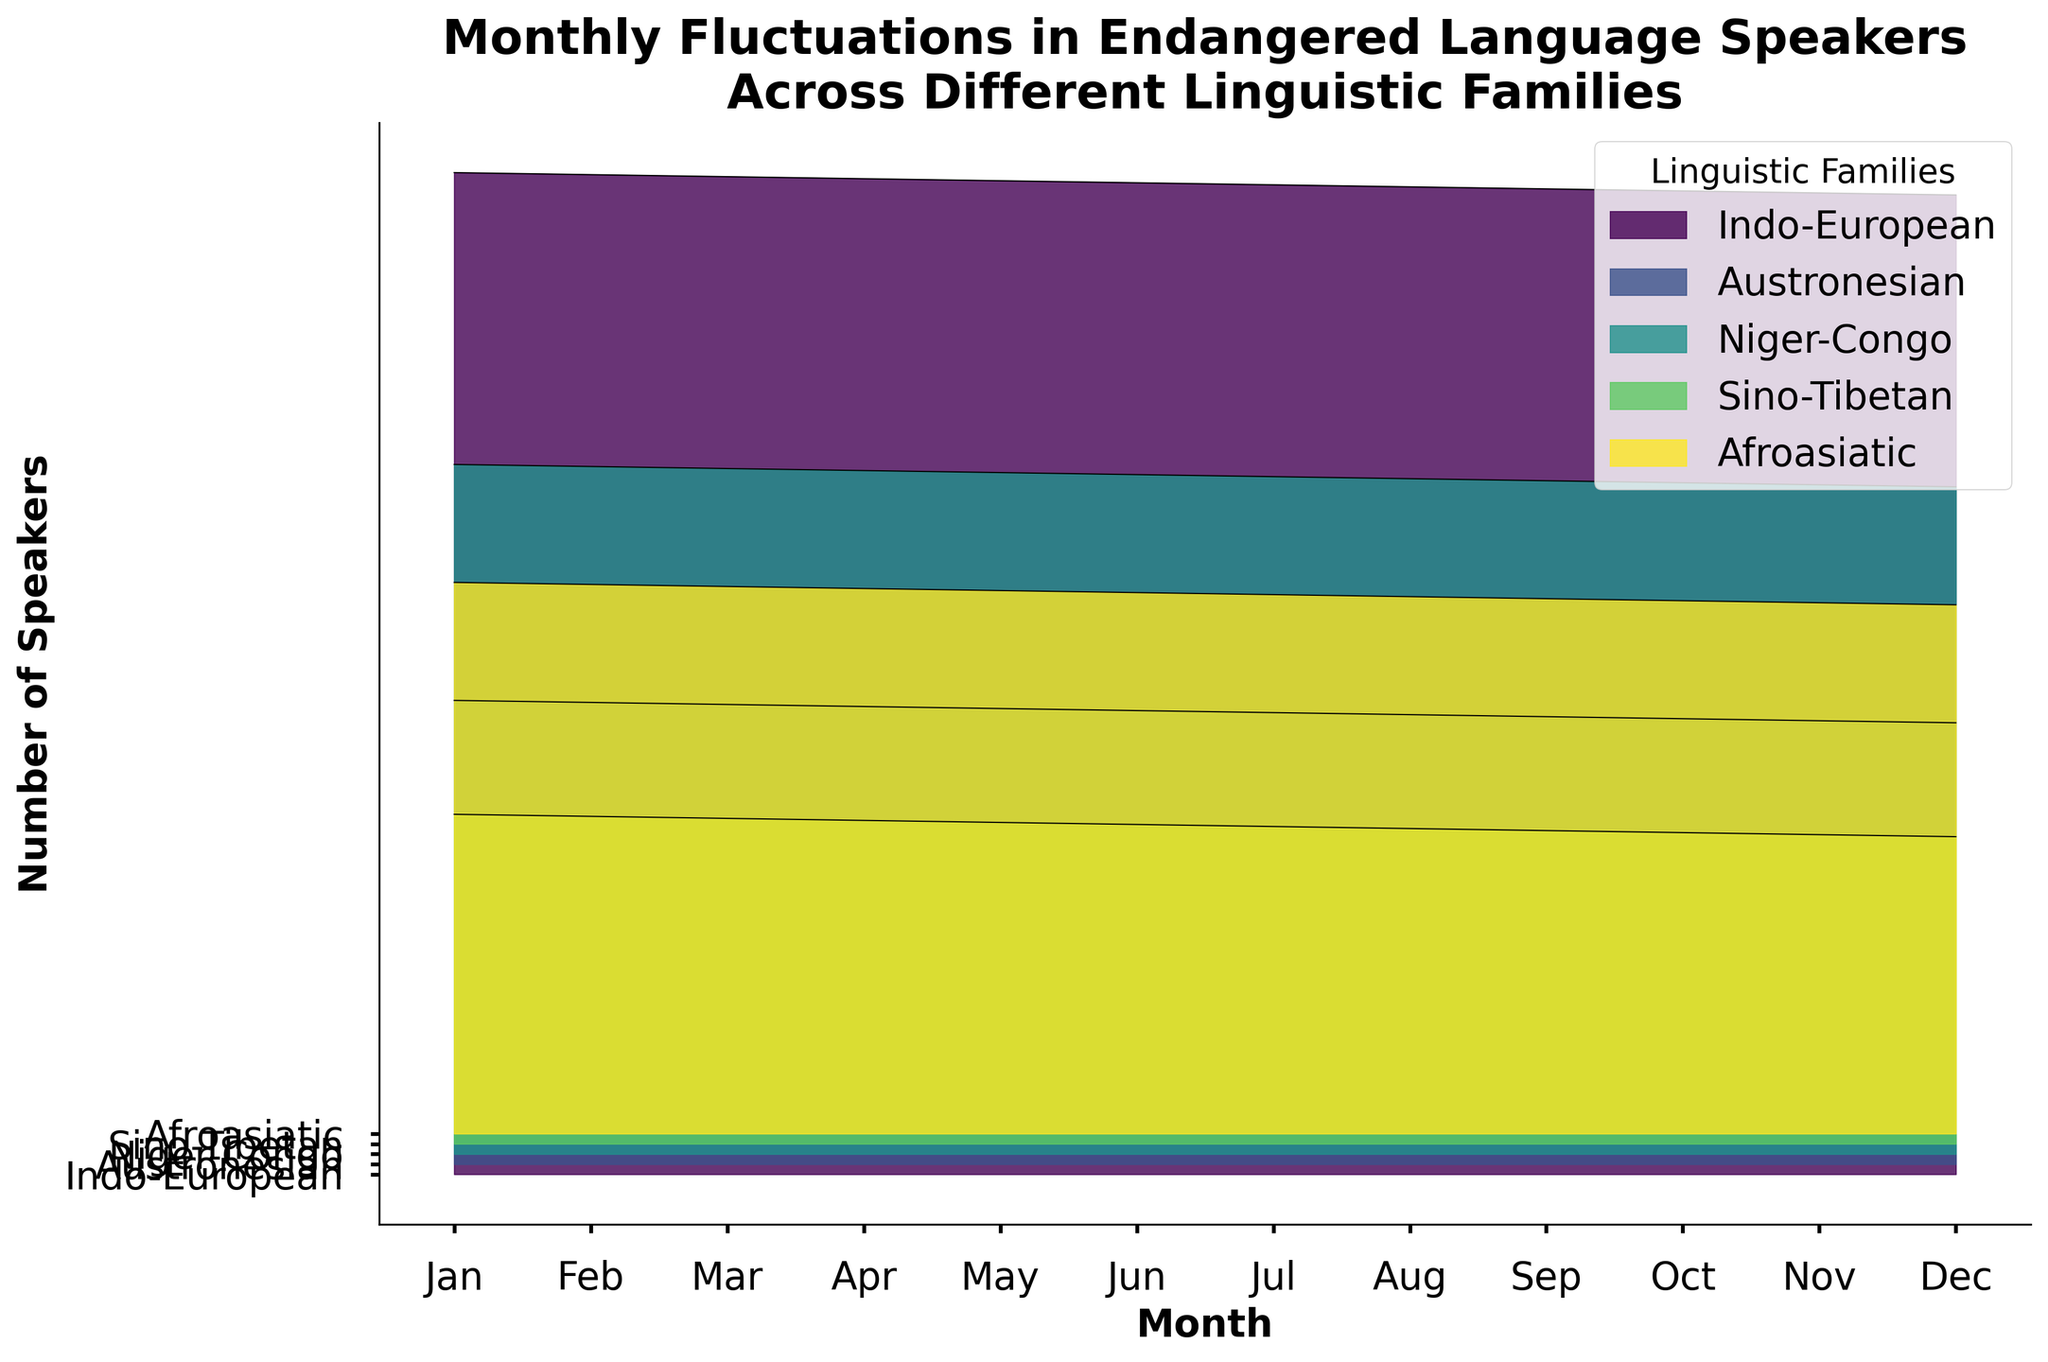What is the title of the plot? The title of the plot is typically located at the top of the figure, and it summarizes the content.
Answer: Monthly Fluctuations in Endangered Language Speakers Across Different Linguistic Families Which linguistic family has the highest number of speakers in January? By observing the Ridgeline plot for the month of January and following the line upwards, we look for the highest peak.
Answer: Indo-European How many linguistic families are presented in the plot? The y-axis of the Ridgeline plot typically lists all the categories. By counting the labels on the y-axis, we determine the number of linguistic families.
Answer: 5 What is the primary color used for the Indo-European linguistic family? By identifying the section related to the Indo-European family in the plot, we observe the color fill used.
Answer: Green What is the difference in the number of speakers between January and February for the Niger-Congo family? Locate the values for January and February for the Niger-Congo family and subtract the February value from the January value (67800 - 67600).
Answer: 200 Which month shows the lowest number of speakers for the Sino-Tibetan family? By following the line for the Sino-Tibetan family across the months, we identify the lowest point on the graph.
Answer: December Which linguistic family shows the steepest decline in the number of speakers over the year? Examine the slope of the lines for each family from January to December and identify the family with the steepest drop.
Answer: Indo-European How much does the number of speakers change on average each month for the Afroasiatic family? Determine the monthly changes from January to December, sum these changes, and divide by the number of months: ((54200 - 54000) + (54000 - 53800) + ... + (30400 - 30200)). Divide this total by 11 (number of months). Detailed calculation shows average change = 200.
Answer: 200 Do any linguistic families show an increase in the number of speakers over the year? Observe the trend lines for each linguistic family from January to December and check if any lines slope upwards.
Answer: No Is the number of speakers for the Austronesian family higher in June or August? Compare the heights of the lines for the Austronesian family in June and August.
Answer: June 